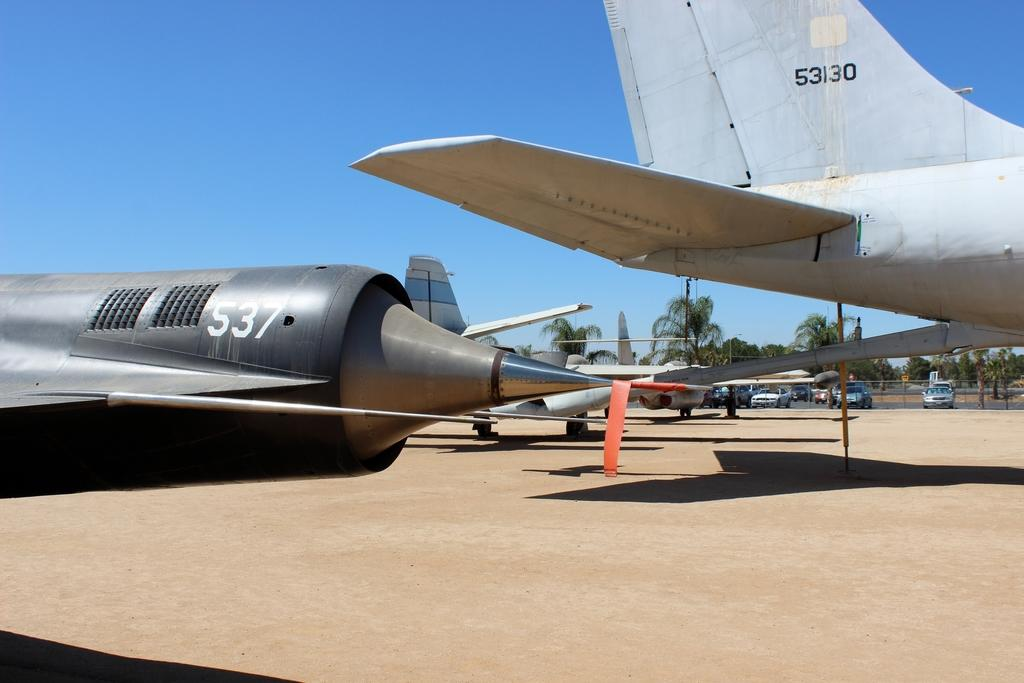<image>
Provide a brief description of the given image. Several small jets lined up in a row, with a jet labeled, "537" in the front of the picture. 